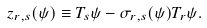Convert formula to latex. <formula><loc_0><loc_0><loc_500><loc_500>z _ { r , s } ( \psi ) \equiv T _ { s } \psi - \sigma _ { r , s } ( \psi ) T _ { r } \psi .</formula> 